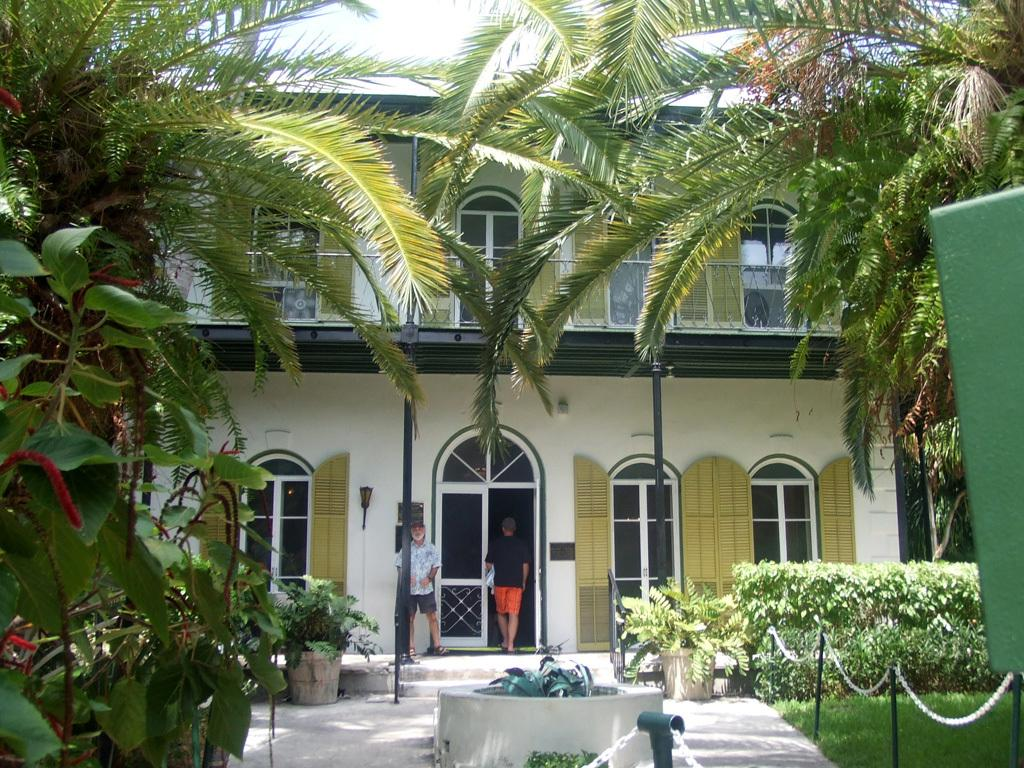What is the main structure visible in the image? There is a building in the image. Where are the two persons located in the image? The two persons are in the center of the image. What type of vegetation can be seen on one side of the image? There are plants on one side of the image. What type of vegetation can be seen on the other side of the image? There are trees on the other side of the image. Can you see any cobwebs in the image? There is no mention of cobwebs in the image, so we cannot determine if any are present. 